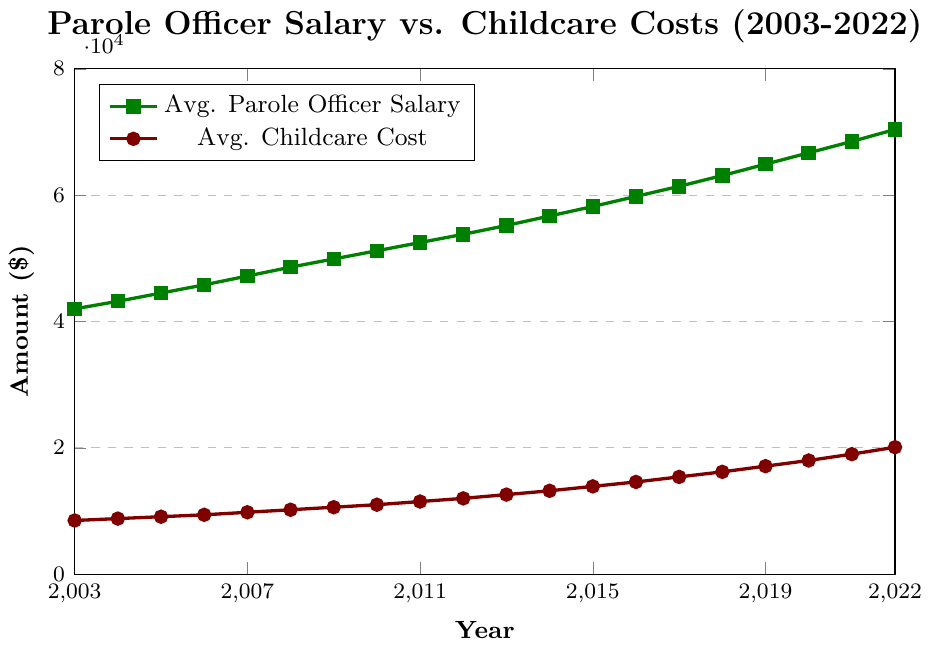What's the overall trend for average parole officer salaries from 2003 to 2022? Observing the green line representing the average parole officer salaries, it shows a steady upward trend from 2003 ($42,000) to 2022 ($70,400).
Answer: Steady upward trend How does the growth rate of average childcare costs compare to that of average parole officer salaries? Both costs have increased over the years, but the average childcare costs (red line) have grown at a faster rate than the average parole officer salaries (green line), indicated by the steeper slope of the red line.
Answer: Childcare costs grew faster Which year saw the highest increase in average parole officer salaries? By observing the height difference year over year for the green line, the highest year-on-year increase is from 2014 ($56,700) to 2015 ($58,200), a difference of $1,500.
Answer: 2015 What is the difference in average childcare costs between 2003 and 2022? The average childcare cost in 2003 is $8,500 and in 2022 is $20,100. The difference is $20,100 - $8,500 = $11,600.
Answer: $11,600 In which year did average childcare costs exceed $15,000? Referring to the red line, average childcare costs first exceed $15,000 in 2017 ($15,400).
Answer: 2017 Was there any year where the increase in average childcare costs was exactly $1,000? By checking the yearly increase for the red line, no year shows an exact $1,000 increase; however, several have increases close to it.
Answer: No What is the ratio of average parole officer salaries to average childcare costs in 2022? The average parole officer salary in 2022 is $70,400, and the average childcare cost is $20,100. The ratio is $70,400 / $20,100 ≈ 3.5.
Answer: 3.5 What is the percentage increase in average parole officer salaries from 2003 to 2022? The percentage increase can be calculated as: ((70,400 - 42,000) / 42,000) * 100%, which equals approximately 67.62%.
Answer: 67.62% How much more did childcare costs increase compared to parole officer salaries over the 20 years? The increase in childcare costs from 2003 to 2022 is $20,100 - $8,500 = $11,600. The increase in parole officer salaries from 2003 to 2022 is $70,400 - $42,000 = $28,400. Childcare costs increased by $11,600 whereas salaries increased by $28,400.
Answer: $16,800 less 